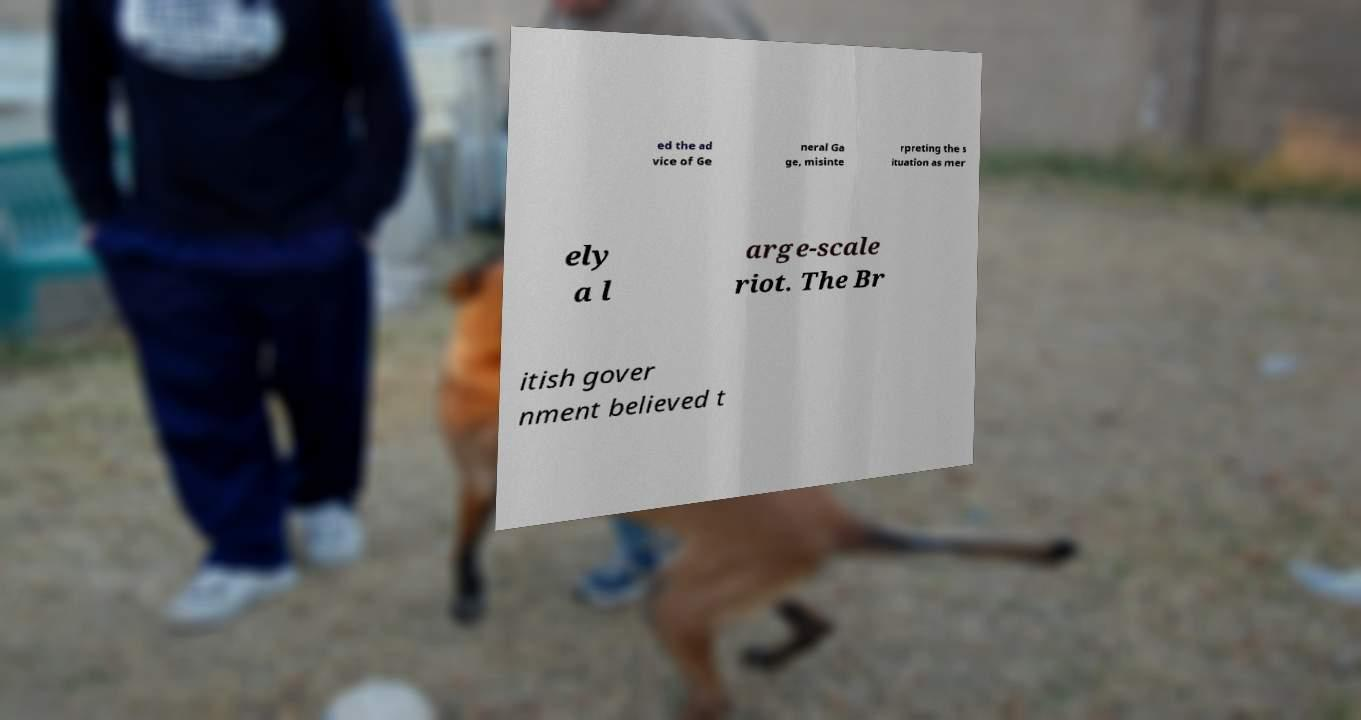Can you accurately transcribe the text from the provided image for me? ed the ad vice of Ge neral Ga ge, misinte rpreting the s ituation as mer ely a l arge-scale riot. The Br itish gover nment believed t 